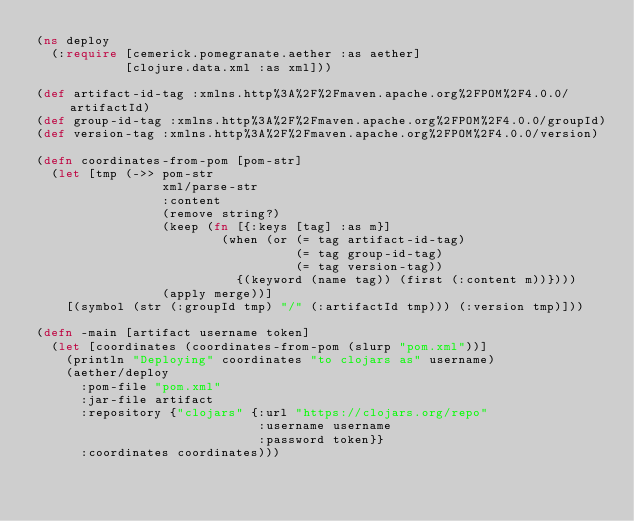Convert code to text. <code><loc_0><loc_0><loc_500><loc_500><_Clojure_>(ns deploy
  (:require [cemerick.pomegranate.aether :as aether]
            [clojure.data.xml :as xml]))

(def artifact-id-tag :xmlns.http%3A%2F%2Fmaven.apache.org%2FPOM%2F4.0.0/artifactId)
(def group-id-tag :xmlns.http%3A%2F%2Fmaven.apache.org%2FPOM%2F4.0.0/groupId)
(def version-tag :xmlns.http%3A%2F%2Fmaven.apache.org%2FPOM%2F4.0.0/version)

(defn coordinates-from-pom [pom-str]
  (let [tmp (->> pom-str
                 xml/parse-str
                 :content
                 (remove string?)
                 (keep (fn [{:keys [tag] :as m}]
                         (when (or (= tag artifact-id-tag)
                                   (= tag group-id-tag)
                                   (= tag version-tag))
                           {(keyword (name tag)) (first (:content m))})))
                 (apply merge))]
    [(symbol (str (:groupId tmp) "/" (:artifactId tmp))) (:version tmp)]))

(defn -main [artifact username token]
  (let [coordinates (coordinates-from-pom (slurp "pom.xml"))]
    (println "Deploying" coordinates "to clojars as" username)
    (aether/deploy
      :pom-file "pom.xml"
      :jar-file artifact
      :repository {"clojars" {:url "https://clojars.org/repo"
                              :username username
                              :password token}}
      :coordinates coordinates)))

</code> 